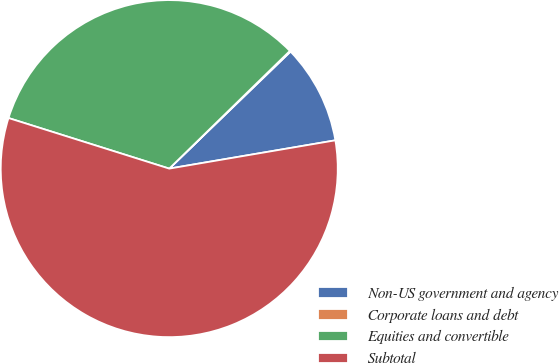Convert chart to OTSL. <chart><loc_0><loc_0><loc_500><loc_500><pie_chart><fcel>Non-US government and agency<fcel>Corporate loans and debt<fcel>Equities and convertible<fcel>Subtotal<nl><fcel>9.53%<fcel>0.09%<fcel>32.84%<fcel>57.53%<nl></chart> 